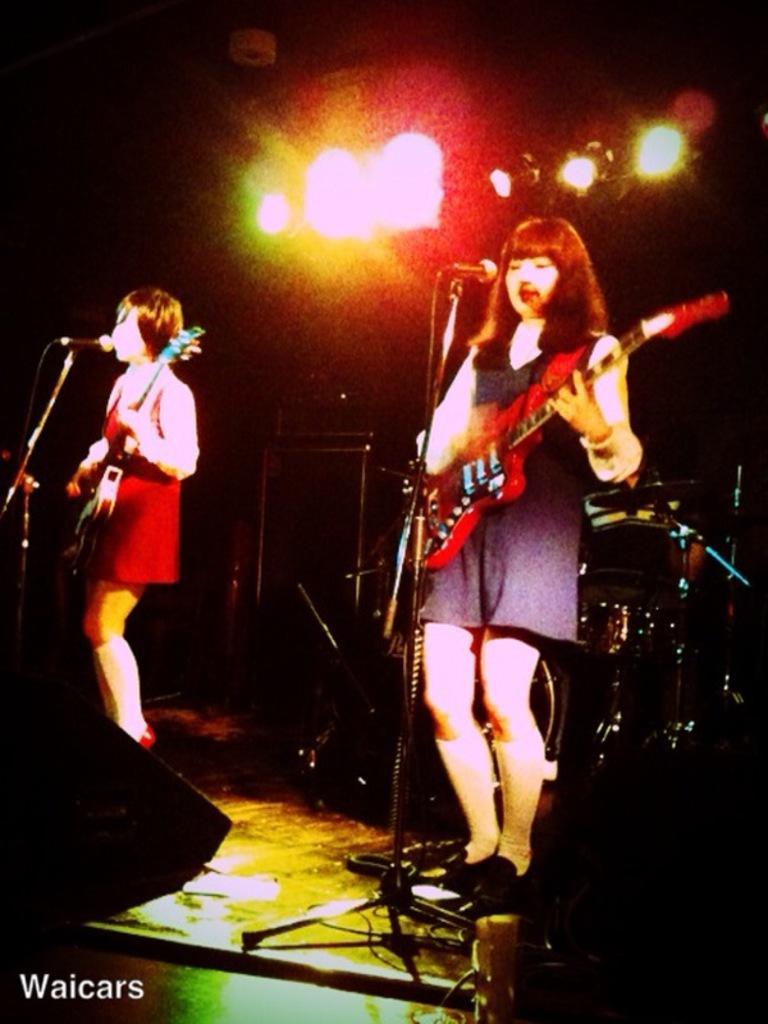How would you summarize this image in a sentence or two? In this image i can see 2 women standing and holding guitars in their hands. I can see microphones in front of them. In the background i can see lights. 